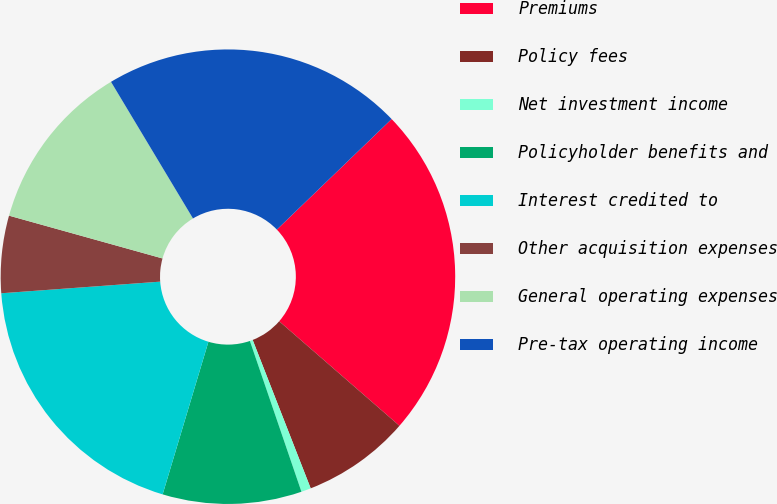Convert chart. <chart><loc_0><loc_0><loc_500><loc_500><pie_chart><fcel>Premiums<fcel>Policy fees<fcel>Net investment income<fcel>Policyholder benefits and<fcel>Interest credited to<fcel>Other acquisition expenses<fcel>General operating expenses<fcel>Pre-tax operating income<nl><fcel>23.59%<fcel>7.68%<fcel>0.69%<fcel>9.88%<fcel>19.2%<fcel>5.49%<fcel>12.07%<fcel>21.4%<nl></chart> 